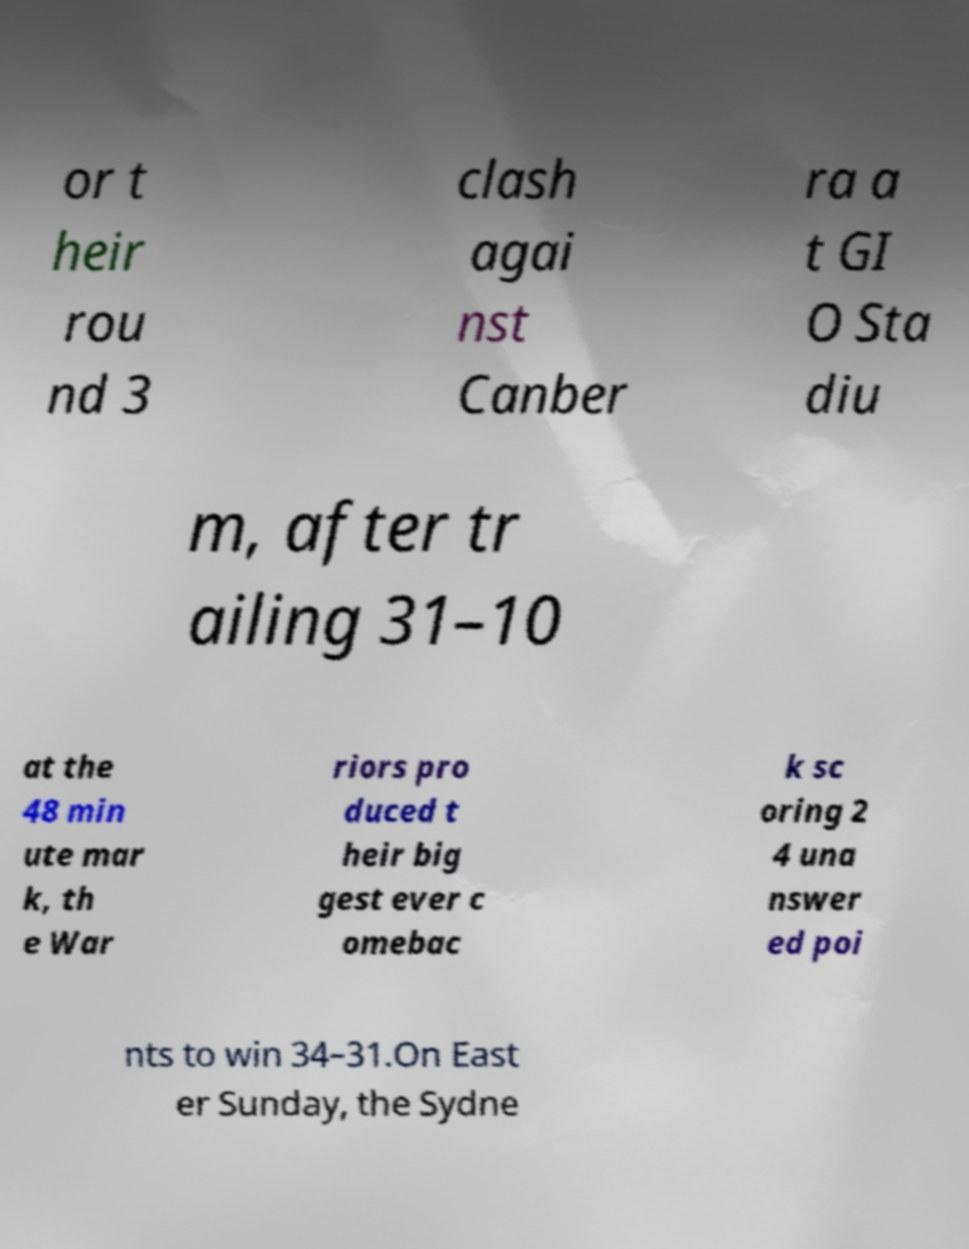Can you read and provide the text displayed in the image?This photo seems to have some interesting text. Can you extract and type it out for me? or t heir rou nd 3 clash agai nst Canber ra a t GI O Sta diu m, after tr ailing 31–10 at the 48 min ute mar k, th e War riors pro duced t heir big gest ever c omebac k sc oring 2 4 una nswer ed poi nts to win 34–31.On East er Sunday, the Sydne 